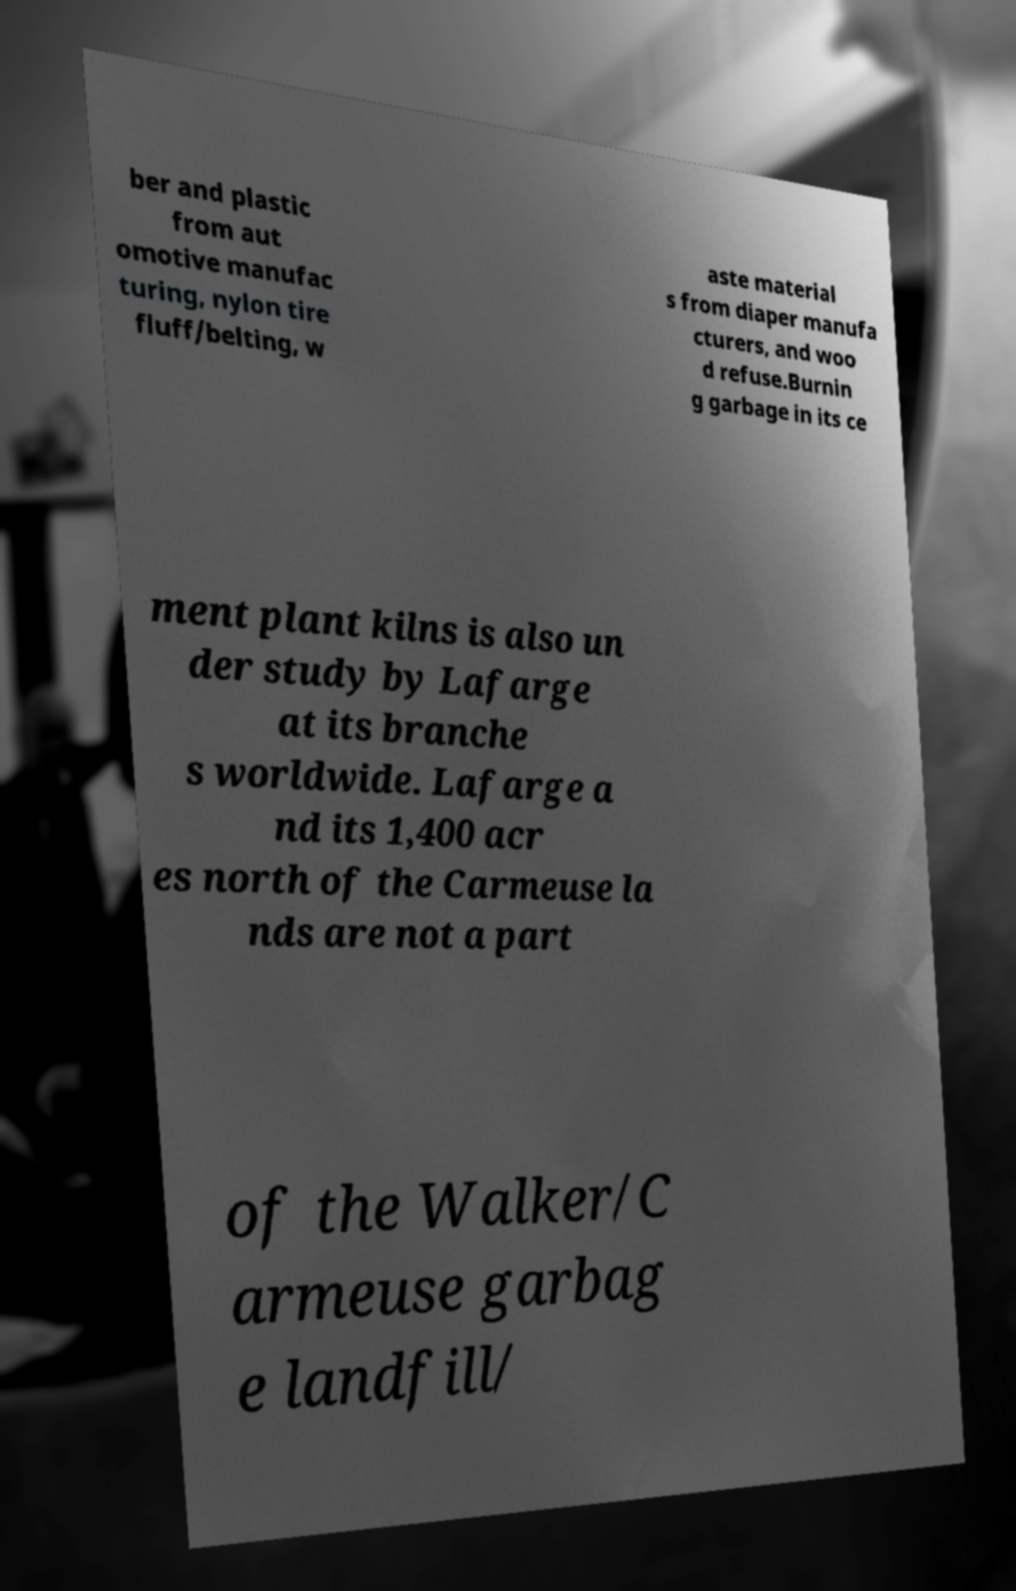For documentation purposes, I need the text within this image transcribed. Could you provide that? ber and plastic from aut omotive manufac turing, nylon tire fluff/belting, w aste material s from diaper manufa cturers, and woo d refuse.Burnin g garbage in its ce ment plant kilns is also un der study by Lafarge at its branche s worldwide. Lafarge a nd its 1,400 acr es north of the Carmeuse la nds are not a part of the Walker/C armeuse garbag e landfill/ 